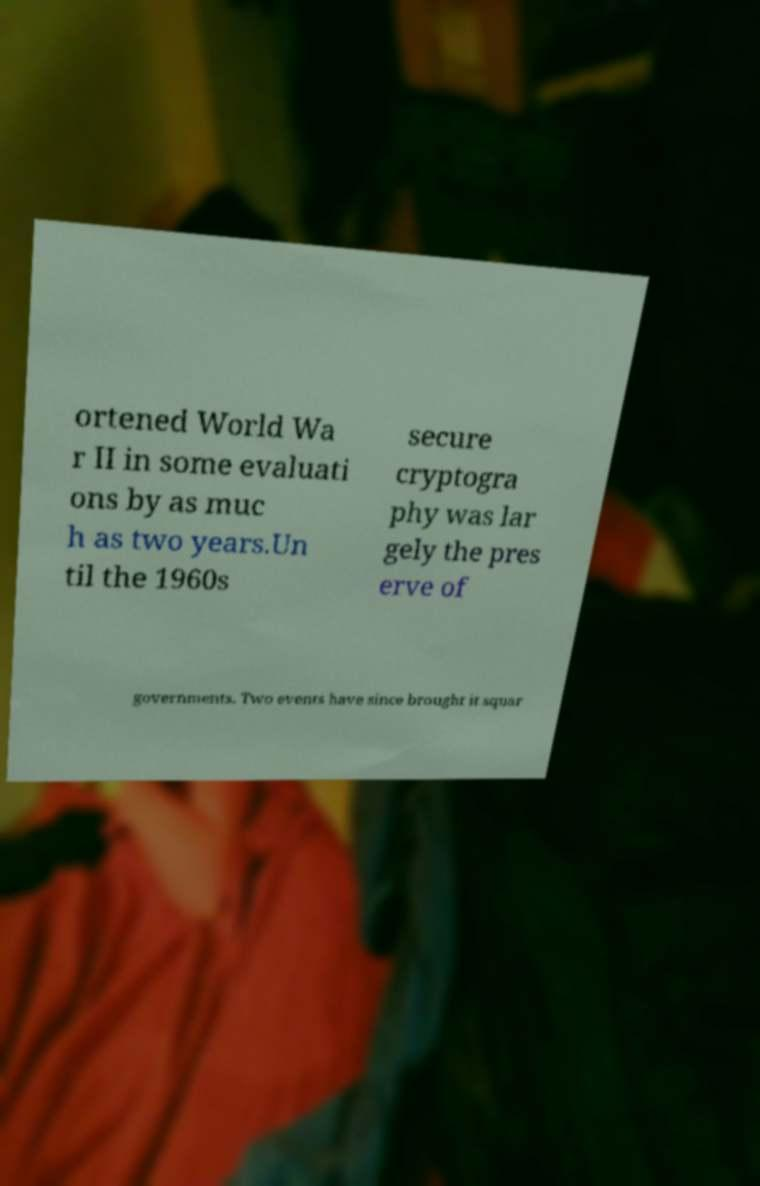Can you accurately transcribe the text from the provided image for me? ortened World Wa r II in some evaluati ons by as muc h as two years.Un til the 1960s secure cryptogra phy was lar gely the pres erve of governments. Two events have since brought it squar 